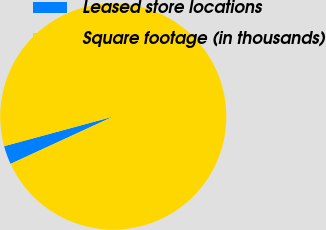Convert chart. <chart><loc_0><loc_0><loc_500><loc_500><pie_chart><fcel>Leased store locations<fcel>Square footage (in thousands)<nl><fcel>2.65%<fcel>97.35%<nl></chart> 